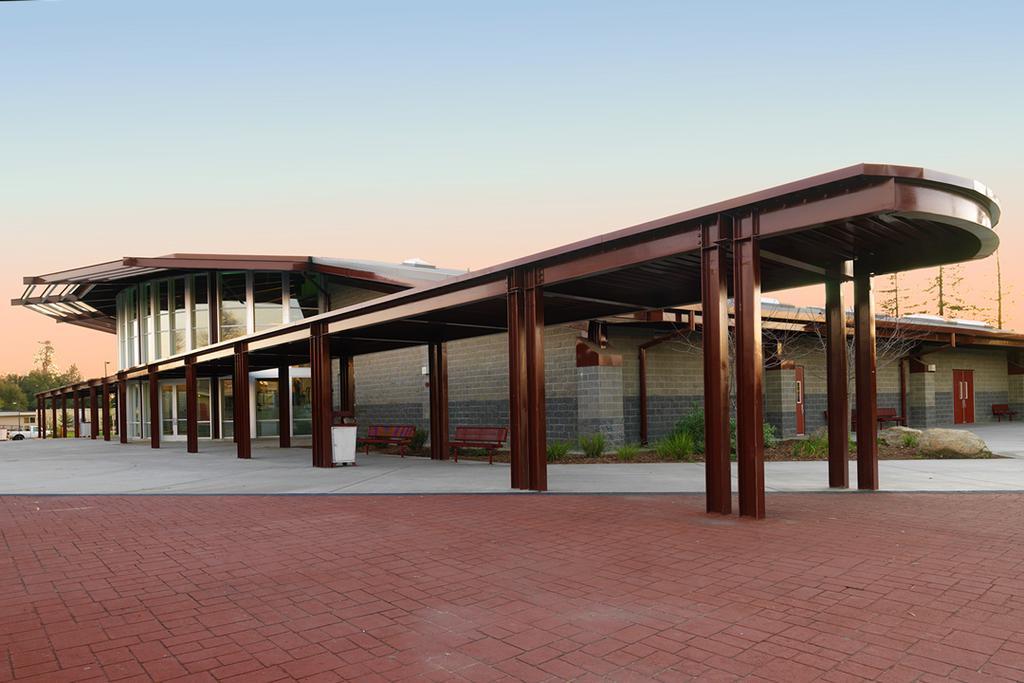In one or two sentences, can you explain what this image depicts? In this image there is the sky truncated towards the top of the image, there is a building truncated towards the right of the image, there are pillars, there are benches, there is an object on the ground, there are plants, there is a vehicle, there is a tree truncated towards the left of the image. 